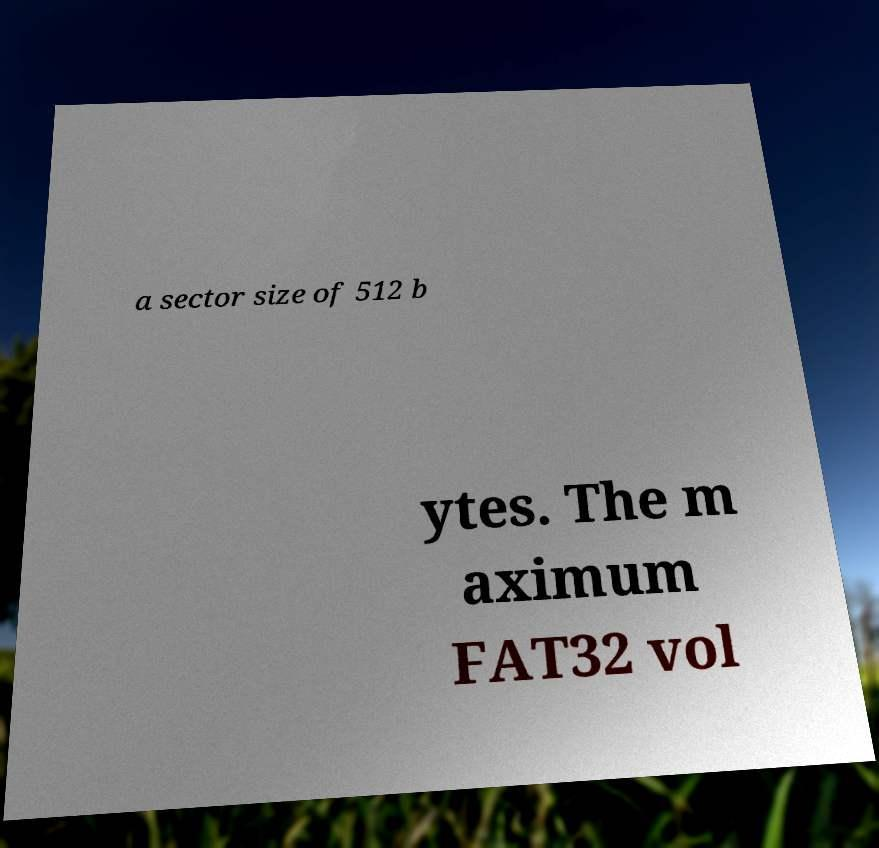Could you extract and type out the text from this image? a sector size of 512 b ytes. The m aximum FAT32 vol 